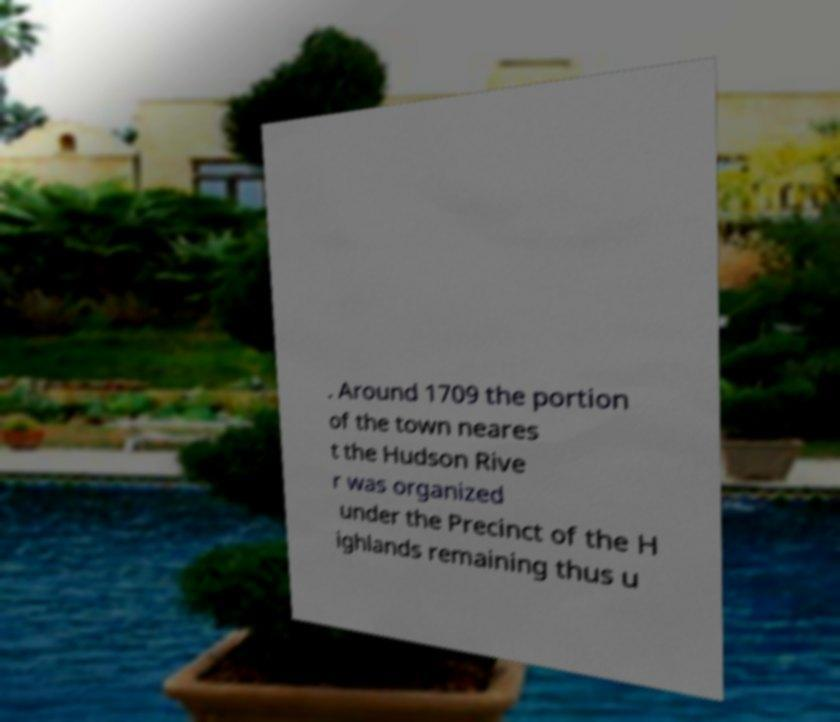Could you assist in decoding the text presented in this image and type it out clearly? . Around 1709 the portion of the town neares t the Hudson Rive r was organized under the Precinct of the H ighlands remaining thus u 